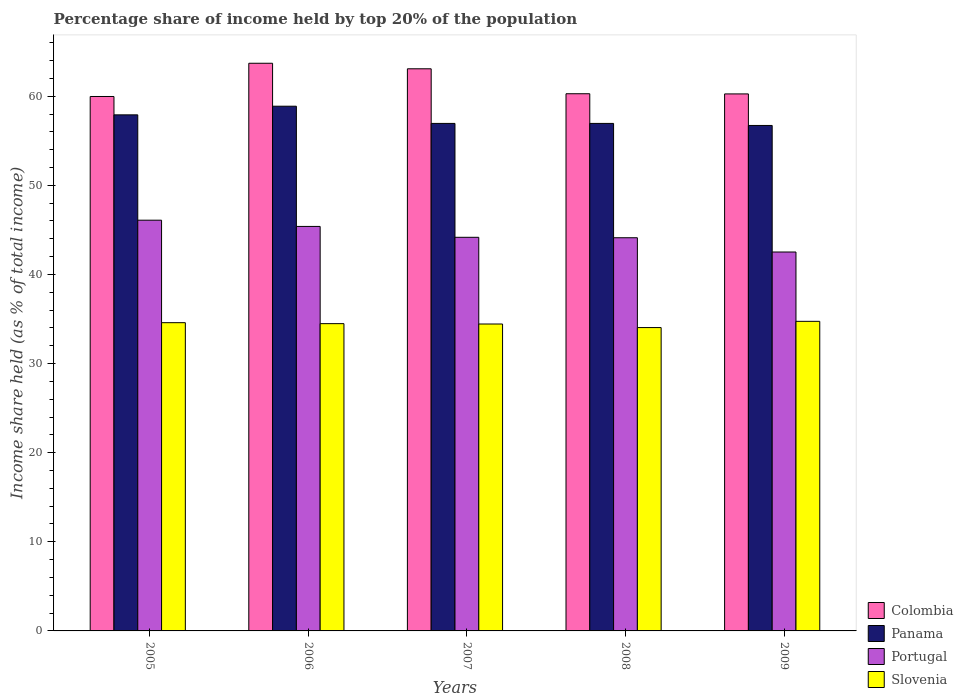Are the number of bars per tick equal to the number of legend labels?
Ensure brevity in your answer.  Yes. How many bars are there on the 5th tick from the right?
Provide a succinct answer. 4. What is the label of the 3rd group of bars from the left?
Keep it short and to the point. 2007. In how many cases, is the number of bars for a given year not equal to the number of legend labels?
Ensure brevity in your answer.  0. What is the percentage share of income held by top 20% of the population in Panama in 2009?
Keep it short and to the point. 56.72. Across all years, what is the maximum percentage share of income held by top 20% of the population in Panama?
Keep it short and to the point. 58.88. Across all years, what is the minimum percentage share of income held by top 20% of the population in Portugal?
Offer a terse response. 42.52. What is the total percentage share of income held by top 20% of the population in Portugal in the graph?
Give a very brief answer. 222.29. What is the difference between the percentage share of income held by top 20% of the population in Portugal in 2005 and that in 2009?
Give a very brief answer. 3.57. What is the difference between the percentage share of income held by top 20% of the population in Portugal in 2009 and the percentage share of income held by top 20% of the population in Slovenia in 2006?
Give a very brief answer. 8.04. What is the average percentage share of income held by top 20% of the population in Colombia per year?
Your response must be concise. 61.46. In the year 2008, what is the difference between the percentage share of income held by top 20% of the population in Portugal and percentage share of income held by top 20% of the population in Panama?
Make the answer very short. -12.83. What is the ratio of the percentage share of income held by top 20% of the population in Colombia in 2005 to that in 2009?
Give a very brief answer. 1. Is the percentage share of income held by top 20% of the population in Portugal in 2006 less than that in 2008?
Make the answer very short. No. What is the difference between the highest and the second highest percentage share of income held by top 20% of the population in Colombia?
Keep it short and to the point. 0.62. What is the difference between the highest and the lowest percentage share of income held by top 20% of the population in Panama?
Provide a succinct answer. 2.16. Is the sum of the percentage share of income held by top 20% of the population in Slovenia in 2005 and 2007 greater than the maximum percentage share of income held by top 20% of the population in Portugal across all years?
Offer a terse response. Yes. Is it the case that in every year, the sum of the percentage share of income held by top 20% of the population in Panama and percentage share of income held by top 20% of the population in Portugal is greater than the sum of percentage share of income held by top 20% of the population in Slovenia and percentage share of income held by top 20% of the population in Colombia?
Your response must be concise. No. What does the 3rd bar from the left in 2005 represents?
Provide a succinct answer. Portugal. What does the 1st bar from the right in 2005 represents?
Keep it short and to the point. Slovenia. How many bars are there?
Provide a short and direct response. 20. What is the difference between two consecutive major ticks on the Y-axis?
Ensure brevity in your answer.  10. Are the values on the major ticks of Y-axis written in scientific E-notation?
Offer a very short reply. No. How many legend labels are there?
Ensure brevity in your answer.  4. How are the legend labels stacked?
Provide a succinct answer. Vertical. What is the title of the graph?
Provide a succinct answer. Percentage share of income held by top 20% of the population. Does "Turks and Caicos Islands" appear as one of the legend labels in the graph?
Your answer should be compact. No. What is the label or title of the Y-axis?
Offer a very short reply. Income share held (as % of total income). What is the Income share held (as % of total income) in Colombia in 2005?
Your response must be concise. 59.97. What is the Income share held (as % of total income) of Panama in 2005?
Provide a short and direct response. 57.91. What is the Income share held (as % of total income) in Portugal in 2005?
Make the answer very short. 46.09. What is the Income share held (as % of total income) in Slovenia in 2005?
Give a very brief answer. 34.59. What is the Income share held (as % of total income) of Colombia in 2006?
Your answer should be very brief. 63.7. What is the Income share held (as % of total income) of Panama in 2006?
Ensure brevity in your answer.  58.88. What is the Income share held (as % of total income) in Portugal in 2006?
Provide a short and direct response. 45.39. What is the Income share held (as % of total income) of Slovenia in 2006?
Offer a terse response. 34.48. What is the Income share held (as % of total income) in Colombia in 2007?
Ensure brevity in your answer.  63.08. What is the Income share held (as % of total income) of Panama in 2007?
Offer a very short reply. 56.95. What is the Income share held (as % of total income) in Portugal in 2007?
Keep it short and to the point. 44.17. What is the Income share held (as % of total income) of Slovenia in 2007?
Ensure brevity in your answer.  34.44. What is the Income share held (as % of total income) of Colombia in 2008?
Give a very brief answer. 60.28. What is the Income share held (as % of total income) in Panama in 2008?
Ensure brevity in your answer.  56.95. What is the Income share held (as % of total income) in Portugal in 2008?
Offer a terse response. 44.12. What is the Income share held (as % of total income) of Slovenia in 2008?
Provide a succinct answer. 34.04. What is the Income share held (as % of total income) of Colombia in 2009?
Provide a succinct answer. 60.26. What is the Income share held (as % of total income) of Panama in 2009?
Provide a short and direct response. 56.72. What is the Income share held (as % of total income) in Portugal in 2009?
Offer a very short reply. 42.52. What is the Income share held (as % of total income) of Slovenia in 2009?
Your response must be concise. 34.74. Across all years, what is the maximum Income share held (as % of total income) in Colombia?
Give a very brief answer. 63.7. Across all years, what is the maximum Income share held (as % of total income) in Panama?
Offer a terse response. 58.88. Across all years, what is the maximum Income share held (as % of total income) of Portugal?
Your answer should be very brief. 46.09. Across all years, what is the maximum Income share held (as % of total income) in Slovenia?
Offer a very short reply. 34.74. Across all years, what is the minimum Income share held (as % of total income) of Colombia?
Keep it short and to the point. 59.97. Across all years, what is the minimum Income share held (as % of total income) of Panama?
Your response must be concise. 56.72. Across all years, what is the minimum Income share held (as % of total income) in Portugal?
Give a very brief answer. 42.52. Across all years, what is the minimum Income share held (as % of total income) in Slovenia?
Make the answer very short. 34.04. What is the total Income share held (as % of total income) of Colombia in the graph?
Your answer should be compact. 307.29. What is the total Income share held (as % of total income) in Panama in the graph?
Provide a succinct answer. 287.41. What is the total Income share held (as % of total income) in Portugal in the graph?
Offer a terse response. 222.29. What is the total Income share held (as % of total income) of Slovenia in the graph?
Give a very brief answer. 172.29. What is the difference between the Income share held (as % of total income) of Colombia in 2005 and that in 2006?
Keep it short and to the point. -3.73. What is the difference between the Income share held (as % of total income) of Panama in 2005 and that in 2006?
Keep it short and to the point. -0.97. What is the difference between the Income share held (as % of total income) in Portugal in 2005 and that in 2006?
Make the answer very short. 0.7. What is the difference between the Income share held (as % of total income) in Slovenia in 2005 and that in 2006?
Offer a terse response. 0.11. What is the difference between the Income share held (as % of total income) of Colombia in 2005 and that in 2007?
Your answer should be compact. -3.11. What is the difference between the Income share held (as % of total income) of Portugal in 2005 and that in 2007?
Keep it short and to the point. 1.92. What is the difference between the Income share held (as % of total income) in Slovenia in 2005 and that in 2007?
Offer a very short reply. 0.15. What is the difference between the Income share held (as % of total income) in Colombia in 2005 and that in 2008?
Offer a very short reply. -0.31. What is the difference between the Income share held (as % of total income) of Portugal in 2005 and that in 2008?
Your answer should be very brief. 1.97. What is the difference between the Income share held (as % of total income) in Slovenia in 2005 and that in 2008?
Your answer should be very brief. 0.55. What is the difference between the Income share held (as % of total income) in Colombia in 2005 and that in 2009?
Your answer should be compact. -0.29. What is the difference between the Income share held (as % of total income) in Panama in 2005 and that in 2009?
Provide a succinct answer. 1.19. What is the difference between the Income share held (as % of total income) of Portugal in 2005 and that in 2009?
Make the answer very short. 3.57. What is the difference between the Income share held (as % of total income) of Colombia in 2006 and that in 2007?
Your response must be concise. 0.62. What is the difference between the Income share held (as % of total income) in Panama in 2006 and that in 2007?
Your response must be concise. 1.93. What is the difference between the Income share held (as % of total income) of Portugal in 2006 and that in 2007?
Keep it short and to the point. 1.22. What is the difference between the Income share held (as % of total income) of Slovenia in 2006 and that in 2007?
Your response must be concise. 0.04. What is the difference between the Income share held (as % of total income) of Colombia in 2006 and that in 2008?
Offer a terse response. 3.42. What is the difference between the Income share held (as % of total income) in Panama in 2006 and that in 2008?
Offer a very short reply. 1.93. What is the difference between the Income share held (as % of total income) of Portugal in 2006 and that in 2008?
Ensure brevity in your answer.  1.27. What is the difference between the Income share held (as % of total income) in Slovenia in 2006 and that in 2008?
Offer a terse response. 0.44. What is the difference between the Income share held (as % of total income) of Colombia in 2006 and that in 2009?
Give a very brief answer. 3.44. What is the difference between the Income share held (as % of total income) of Panama in 2006 and that in 2009?
Provide a succinct answer. 2.16. What is the difference between the Income share held (as % of total income) of Portugal in 2006 and that in 2009?
Your answer should be compact. 2.87. What is the difference between the Income share held (as % of total income) in Slovenia in 2006 and that in 2009?
Provide a succinct answer. -0.26. What is the difference between the Income share held (as % of total income) in Panama in 2007 and that in 2008?
Your answer should be very brief. 0. What is the difference between the Income share held (as % of total income) in Colombia in 2007 and that in 2009?
Give a very brief answer. 2.82. What is the difference between the Income share held (as % of total income) of Panama in 2007 and that in 2009?
Make the answer very short. 0.23. What is the difference between the Income share held (as % of total income) in Portugal in 2007 and that in 2009?
Your answer should be very brief. 1.65. What is the difference between the Income share held (as % of total income) in Slovenia in 2007 and that in 2009?
Provide a short and direct response. -0.3. What is the difference between the Income share held (as % of total income) of Colombia in 2008 and that in 2009?
Your response must be concise. 0.02. What is the difference between the Income share held (as % of total income) in Panama in 2008 and that in 2009?
Provide a short and direct response. 0.23. What is the difference between the Income share held (as % of total income) of Portugal in 2008 and that in 2009?
Your answer should be compact. 1.6. What is the difference between the Income share held (as % of total income) in Slovenia in 2008 and that in 2009?
Offer a very short reply. -0.7. What is the difference between the Income share held (as % of total income) in Colombia in 2005 and the Income share held (as % of total income) in Panama in 2006?
Provide a succinct answer. 1.09. What is the difference between the Income share held (as % of total income) in Colombia in 2005 and the Income share held (as % of total income) in Portugal in 2006?
Make the answer very short. 14.58. What is the difference between the Income share held (as % of total income) in Colombia in 2005 and the Income share held (as % of total income) in Slovenia in 2006?
Offer a very short reply. 25.49. What is the difference between the Income share held (as % of total income) in Panama in 2005 and the Income share held (as % of total income) in Portugal in 2006?
Your answer should be compact. 12.52. What is the difference between the Income share held (as % of total income) in Panama in 2005 and the Income share held (as % of total income) in Slovenia in 2006?
Ensure brevity in your answer.  23.43. What is the difference between the Income share held (as % of total income) of Portugal in 2005 and the Income share held (as % of total income) of Slovenia in 2006?
Offer a terse response. 11.61. What is the difference between the Income share held (as % of total income) of Colombia in 2005 and the Income share held (as % of total income) of Panama in 2007?
Offer a very short reply. 3.02. What is the difference between the Income share held (as % of total income) in Colombia in 2005 and the Income share held (as % of total income) in Slovenia in 2007?
Your answer should be compact. 25.53. What is the difference between the Income share held (as % of total income) in Panama in 2005 and the Income share held (as % of total income) in Portugal in 2007?
Your response must be concise. 13.74. What is the difference between the Income share held (as % of total income) in Panama in 2005 and the Income share held (as % of total income) in Slovenia in 2007?
Your answer should be very brief. 23.47. What is the difference between the Income share held (as % of total income) in Portugal in 2005 and the Income share held (as % of total income) in Slovenia in 2007?
Ensure brevity in your answer.  11.65. What is the difference between the Income share held (as % of total income) in Colombia in 2005 and the Income share held (as % of total income) in Panama in 2008?
Keep it short and to the point. 3.02. What is the difference between the Income share held (as % of total income) of Colombia in 2005 and the Income share held (as % of total income) of Portugal in 2008?
Ensure brevity in your answer.  15.85. What is the difference between the Income share held (as % of total income) of Colombia in 2005 and the Income share held (as % of total income) of Slovenia in 2008?
Keep it short and to the point. 25.93. What is the difference between the Income share held (as % of total income) of Panama in 2005 and the Income share held (as % of total income) of Portugal in 2008?
Your answer should be very brief. 13.79. What is the difference between the Income share held (as % of total income) of Panama in 2005 and the Income share held (as % of total income) of Slovenia in 2008?
Keep it short and to the point. 23.87. What is the difference between the Income share held (as % of total income) of Portugal in 2005 and the Income share held (as % of total income) of Slovenia in 2008?
Ensure brevity in your answer.  12.05. What is the difference between the Income share held (as % of total income) in Colombia in 2005 and the Income share held (as % of total income) in Portugal in 2009?
Make the answer very short. 17.45. What is the difference between the Income share held (as % of total income) in Colombia in 2005 and the Income share held (as % of total income) in Slovenia in 2009?
Your response must be concise. 25.23. What is the difference between the Income share held (as % of total income) of Panama in 2005 and the Income share held (as % of total income) of Portugal in 2009?
Your response must be concise. 15.39. What is the difference between the Income share held (as % of total income) of Panama in 2005 and the Income share held (as % of total income) of Slovenia in 2009?
Your answer should be very brief. 23.17. What is the difference between the Income share held (as % of total income) in Portugal in 2005 and the Income share held (as % of total income) in Slovenia in 2009?
Make the answer very short. 11.35. What is the difference between the Income share held (as % of total income) in Colombia in 2006 and the Income share held (as % of total income) in Panama in 2007?
Your answer should be very brief. 6.75. What is the difference between the Income share held (as % of total income) of Colombia in 2006 and the Income share held (as % of total income) of Portugal in 2007?
Offer a terse response. 19.53. What is the difference between the Income share held (as % of total income) in Colombia in 2006 and the Income share held (as % of total income) in Slovenia in 2007?
Provide a succinct answer. 29.26. What is the difference between the Income share held (as % of total income) of Panama in 2006 and the Income share held (as % of total income) of Portugal in 2007?
Your response must be concise. 14.71. What is the difference between the Income share held (as % of total income) of Panama in 2006 and the Income share held (as % of total income) of Slovenia in 2007?
Provide a short and direct response. 24.44. What is the difference between the Income share held (as % of total income) of Portugal in 2006 and the Income share held (as % of total income) of Slovenia in 2007?
Your response must be concise. 10.95. What is the difference between the Income share held (as % of total income) in Colombia in 2006 and the Income share held (as % of total income) in Panama in 2008?
Make the answer very short. 6.75. What is the difference between the Income share held (as % of total income) in Colombia in 2006 and the Income share held (as % of total income) in Portugal in 2008?
Keep it short and to the point. 19.58. What is the difference between the Income share held (as % of total income) in Colombia in 2006 and the Income share held (as % of total income) in Slovenia in 2008?
Offer a very short reply. 29.66. What is the difference between the Income share held (as % of total income) of Panama in 2006 and the Income share held (as % of total income) of Portugal in 2008?
Your answer should be very brief. 14.76. What is the difference between the Income share held (as % of total income) of Panama in 2006 and the Income share held (as % of total income) of Slovenia in 2008?
Give a very brief answer. 24.84. What is the difference between the Income share held (as % of total income) in Portugal in 2006 and the Income share held (as % of total income) in Slovenia in 2008?
Offer a very short reply. 11.35. What is the difference between the Income share held (as % of total income) of Colombia in 2006 and the Income share held (as % of total income) of Panama in 2009?
Provide a short and direct response. 6.98. What is the difference between the Income share held (as % of total income) in Colombia in 2006 and the Income share held (as % of total income) in Portugal in 2009?
Make the answer very short. 21.18. What is the difference between the Income share held (as % of total income) of Colombia in 2006 and the Income share held (as % of total income) of Slovenia in 2009?
Keep it short and to the point. 28.96. What is the difference between the Income share held (as % of total income) in Panama in 2006 and the Income share held (as % of total income) in Portugal in 2009?
Keep it short and to the point. 16.36. What is the difference between the Income share held (as % of total income) of Panama in 2006 and the Income share held (as % of total income) of Slovenia in 2009?
Offer a terse response. 24.14. What is the difference between the Income share held (as % of total income) of Portugal in 2006 and the Income share held (as % of total income) of Slovenia in 2009?
Offer a terse response. 10.65. What is the difference between the Income share held (as % of total income) in Colombia in 2007 and the Income share held (as % of total income) in Panama in 2008?
Make the answer very short. 6.13. What is the difference between the Income share held (as % of total income) in Colombia in 2007 and the Income share held (as % of total income) in Portugal in 2008?
Give a very brief answer. 18.96. What is the difference between the Income share held (as % of total income) of Colombia in 2007 and the Income share held (as % of total income) of Slovenia in 2008?
Provide a short and direct response. 29.04. What is the difference between the Income share held (as % of total income) in Panama in 2007 and the Income share held (as % of total income) in Portugal in 2008?
Ensure brevity in your answer.  12.83. What is the difference between the Income share held (as % of total income) in Panama in 2007 and the Income share held (as % of total income) in Slovenia in 2008?
Provide a succinct answer. 22.91. What is the difference between the Income share held (as % of total income) in Portugal in 2007 and the Income share held (as % of total income) in Slovenia in 2008?
Make the answer very short. 10.13. What is the difference between the Income share held (as % of total income) of Colombia in 2007 and the Income share held (as % of total income) of Panama in 2009?
Your answer should be very brief. 6.36. What is the difference between the Income share held (as % of total income) of Colombia in 2007 and the Income share held (as % of total income) of Portugal in 2009?
Give a very brief answer. 20.56. What is the difference between the Income share held (as % of total income) of Colombia in 2007 and the Income share held (as % of total income) of Slovenia in 2009?
Make the answer very short. 28.34. What is the difference between the Income share held (as % of total income) in Panama in 2007 and the Income share held (as % of total income) in Portugal in 2009?
Provide a succinct answer. 14.43. What is the difference between the Income share held (as % of total income) of Panama in 2007 and the Income share held (as % of total income) of Slovenia in 2009?
Offer a terse response. 22.21. What is the difference between the Income share held (as % of total income) of Portugal in 2007 and the Income share held (as % of total income) of Slovenia in 2009?
Ensure brevity in your answer.  9.43. What is the difference between the Income share held (as % of total income) of Colombia in 2008 and the Income share held (as % of total income) of Panama in 2009?
Make the answer very short. 3.56. What is the difference between the Income share held (as % of total income) in Colombia in 2008 and the Income share held (as % of total income) in Portugal in 2009?
Your response must be concise. 17.76. What is the difference between the Income share held (as % of total income) in Colombia in 2008 and the Income share held (as % of total income) in Slovenia in 2009?
Make the answer very short. 25.54. What is the difference between the Income share held (as % of total income) of Panama in 2008 and the Income share held (as % of total income) of Portugal in 2009?
Your answer should be very brief. 14.43. What is the difference between the Income share held (as % of total income) of Panama in 2008 and the Income share held (as % of total income) of Slovenia in 2009?
Give a very brief answer. 22.21. What is the difference between the Income share held (as % of total income) in Portugal in 2008 and the Income share held (as % of total income) in Slovenia in 2009?
Your response must be concise. 9.38. What is the average Income share held (as % of total income) in Colombia per year?
Offer a terse response. 61.46. What is the average Income share held (as % of total income) in Panama per year?
Offer a very short reply. 57.48. What is the average Income share held (as % of total income) in Portugal per year?
Offer a terse response. 44.46. What is the average Income share held (as % of total income) of Slovenia per year?
Ensure brevity in your answer.  34.46. In the year 2005, what is the difference between the Income share held (as % of total income) of Colombia and Income share held (as % of total income) of Panama?
Keep it short and to the point. 2.06. In the year 2005, what is the difference between the Income share held (as % of total income) of Colombia and Income share held (as % of total income) of Portugal?
Ensure brevity in your answer.  13.88. In the year 2005, what is the difference between the Income share held (as % of total income) in Colombia and Income share held (as % of total income) in Slovenia?
Provide a succinct answer. 25.38. In the year 2005, what is the difference between the Income share held (as % of total income) of Panama and Income share held (as % of total income) of Portugal?
Provide a short and direct response. 11.82. In the year 2005, what is the difference between the Income share held (as % of total income) in Panama and Income share held (as % of total income) in Slovenia?
Offer a very short reply. 23.32. In the year 2006, what is the difference between the Income share held (as % of total income) in Colombia and Income share held (as % of total income) in Panama?
Make the answer very short. 4.82. In the year 2006, what is the difference between the Income share held (as % of total income) in Colombia and Income share held (as % of total income) in Portugal?
Provide a short and direct response. 18.31. In the year 2006, what is the difference between the Income share held (as % of total income) in Colombia and Income share held (as % of total income) in Slovenia?
Your response must be concise. 29.22. In the year 2006, what is the difference between the Income share held (as % of total income) in Panama and Income share held (as % of total income) in Portugal?
Provide a succinct answer. 13.49. In the year 2006, what is the difference between the Income share held (as % of total income) of Panama and Income share held (as % of total income) of Slovenia?
Give a very brief answer. 24.4. In the year 2006, what is the difference between the Income share held (as % of total income) of Portugal and Income share held (as % of total income) of Slovenia?
Offer a terse response. 10.91. In the year 2007, what is the difference between the Income share held (as % of total income) in Colombia and Income share held (as % of total income) in Panama?
Keep it short and to the point. 6.13. In the year 2007, what is the difference between the Income share held (as % of total income) of Colombia and Income share held (as % of total income) of Portugal?
Ensure brevity in your answer.  18.91. In the year 2007, what is the difference between the Income share held (as % of total income) of Colombia and Income share held (as % of total income) of Slovenia?
Provide a short and direct response. 28.64. In the year 2007, what is the difference between the Income share held (as % of total income) in Panama and Income share held (as % of total income) in Portugal?
Ensure brevity in your answer.  12.78. In the year 2007, what is the difference between the Income share held (as % of total income) in Panama and Income share held (as % of total income) in Slovenia?
Make the answer very short. 22.51. In the year 2007, what is the difference between the Income share held (as % of total income) in Portugal and Income share held (as % of total income) in Slovenia?
Offer a terse response. 9.73. In the year 2008, what is the difference between the Income share held (as % of total income) of Colombia and Income share held (as % of total income) of Panama?
Keep it short and to the point. 3.33. In the year 2008, what is the difference between the Income share held (as % of total income) in Colombia and Income share held (as % of total income) in Portugal?
Offer a terse response. 16.16. In the year 2008, what is the difference between the Income share held (as % of total income) in Colombia and Income share held (as % of total income) in Slovenia?
Provide a short and direct response. 26.24. In the year 2008, what is the difference between the Income share held (as % of total income) in Panama and Income share held (as % of total income) in Portugal?
Offer a terse response. 12.83. In the year 2008, what is the difference between the Income share held (as % of total income) in Panama and Income share held (as % of total income) in Slovenia?
Offer a terse response. 22.91. In the year 2008, what is the difference between the Income share held (as % of total income) in Portugal and Income share held (as % of total income) in Slovenia?
Offer a terse response. 10.08. In the year 2009, what is the difference between the Income share held (as % of total income) in Colombia and Income share held (as % of total income) in Panama?
Ensure brevity in your answer.  3.54. In the year 2009, what is the difference between the Income share held (as % of total income) in Colombia and Income share held (as % of total income) in Portugal?
Ensure brevity in your answer.  17.74. In the year 2009, what is the difference between the Income share held (as % of total income) in Colombia and Income share held (as % of total income) in Slovenia?
Your answer should be compact. 25.52. In the year 2009, what is the difference between the Income share held (as % of total income) of Panama and Income share held (as % of total income) of Portugal?
Your response must be concise. 14.2. In the year 2009, what is the difference between the Income share held (as % of total income) of Panama and Income share held (as % of total income) of Slovenia?
Offer a very short reply. 21.98. In the year 2009, what is the difference between the Income share held (as % of total income) in Portugal and Income share held (as % of total income) in Slovenia?
Your answer should be compact. 7.78. What is the ratio of the Income share held (as % of total income) of Colombia in 2005 to that in 2006?
Your answer should be very brief. 0.94. What is the ratio of the Income share held (as % of total income) in Panama in 2005 to that in 2006?
Make the answer very short. 0.98. What is the ratio of the Income share held (as % of total income) of Portugal in 2005 to that in 2006?
Keep it short and to the point. 1.02. What is the ratio of the Income share held (as % of total income) of Slovenia in 2005 to that in 2006?
Your response must be concise. 1. What is the ratio of the Income share held (as % of total income) in Colombia in 2005 to that in 2007?
Provide a succinct answer. 0.95. What is the ratio of the Income share held (as % of total income) in Panama in 2005 to that in 2007?
Offer a terse response. 1.02. What is the ratio of the Income share held (as % of total income) of Portugal in 2005 to that in 2007?
Provide a short and direct response. 1.04. What is the ratio of the Income share held (as % of total income) of Slovenia in 2005 to that in 2007?
Your answer should be compact. 1. What is the ratio of the Income share held (as % of total income) in Panama in 2005 to that in 2008?
Your answer should be compact. 1.02. What is the ratio of the Income share held (as % of total income) in Portugal in 2005 to that in 2008?
Provide a short and direct response. 1.04. What is the ratio of the Income share held (as % of total income) in Slovenia in 2005 to that in 2008?
Your response must be concise. 1.02. What is the ratio of the Income share held (as % of total income) of Colombia in 2005 to that in 2009?
Provide a short and direct response. 1. What is the ratio of the Income share held (as % of total income) in Panama in 2005 to that in 2009?
Your answer should be very brief. 1.02. What is the ratio of the Income share held (as % of total income) in Portugal in 2005 to that in 2009?
Ensure brevity in your answer.  1.08. What is the ratio of the Income share held (as % of total income) in Slovenia in 2005 to that in 2009?
Your response must be concise. 1. What is the ratio of the Income share held (as % of total income) of Colombia in 2006 to that in 2007?
Ensure brevity in your answer.  1.01. What is the ratio of the Income share held (as % of total income) in Panama in 2006 to that in 2007?
Your response must be concise. 1.03. What is the ratio of the Income share held (as % of total income) in Portugal in 2006 to that in 2007?
Keep it short and to the point. 1.03. What is the ratio of the Income share held (as % of total income) of Colombia in 2006 to that in 2008?
Your response must be concise. 1.06. What is the ratio of the Income share held (as % of total income) of Panama in 2006 to that in 2008?
Your answer should be compact. 1.03. What is the ratio of the Income share held (as % of total income) in Portugal in 2006 to that in 2008?
Make the answer very short. 1.03. What is the ratio of the Income share held (as % of total income) of Slovenia in 2006 to that in 2008?
Your answer should be very brief. 1.01. What is the ratio of the Income share held (as % of total income) of Colombia in 2006 to that in 2009?
Provide a succinct answer. 1.06. What is the ratio of the Income share held (as % of total income) in Panama in 2006 to that in 2009?
Offer a terse response. 1.04. What is the ratio of the Income share held (as % of total income) in Portugal in 2006 to that in 2009?
Your answer should be very brief. 1.07. What is the ratio of the Income share held (as % of total income) of Colombia in 2007 to that in 2008?
Provide a succinct answer. 1.05. What is the ratio of the Income share held (as % of total income) in Portugal in 2007 to that in 2008?
Your answer should be compact. 1. What is the ratio of the Income share held (as % of total income) in Slovenia in 2007 to that in 2008?
Ensure brevity in your answer.  1.01. What is the ratio of the Income share held (as % of total income) of Colombia in 2007 to that in 2009?
Provide a succinct answer. 1.05. What is the ratio of the Income share held (as % of total income) of Portugal in 2007 to that in 2009?
Your answer should be compact. 1.04. What is the ratio of the Income share held (as % of total income) of Slovenia in 2007 to that in 2009?
Your answer should be compact. 0.99. What is the ratio of the Income share held (as % of total income) of Panama in 2008 to that in 2009?
Keep it short and to the point. 1. What is the ratio of the Income share held (as % of total income) in Portugal in 2008 to that in 2009?
Offer a very short reply. 1.04. What is the ratio of the Income share held (as % of total income) of Slovenia in 2008 to that in 2009?
Provide a short and direct response. 0.98. What is the difference between the highest and the second highest Income share held (as % of total income) in Colombia?
Provide a short and direct response. 0.62. What is the difference between the highest and the second highest Income share held (as % of total income) of Slovenia?
Provide a short and direct response. 0.15. What is the difference between the highest and the lowest Income share held (as % of total income) of Colombia?
Offer a very short reply. 3.73. What is the difference between the highest and the lowest Income share held (as % of total income) of Panama?
Provide a succinct answer. 2.16. What is the difference between the highest and the lowest Income share held (as % of total income) of Portugal?
Offer a terse response. 3.57. 